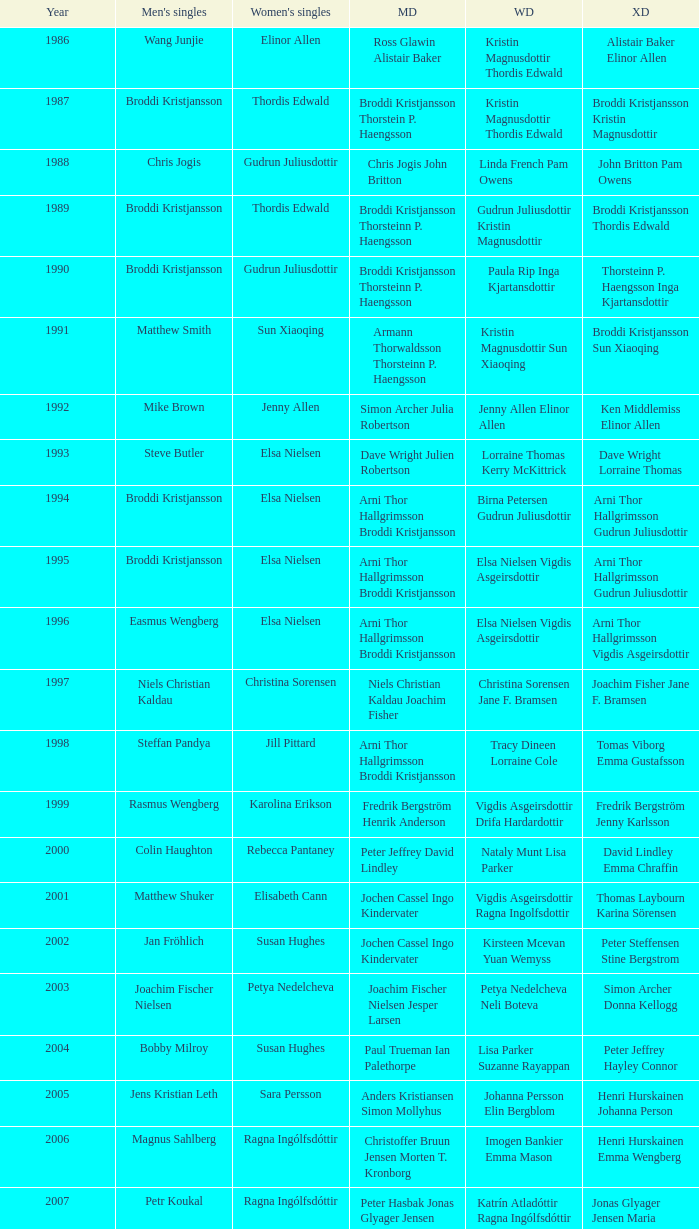Which mixed doubles happened later than 2011? Chou Tien-chen Chiang Mei-hui. 